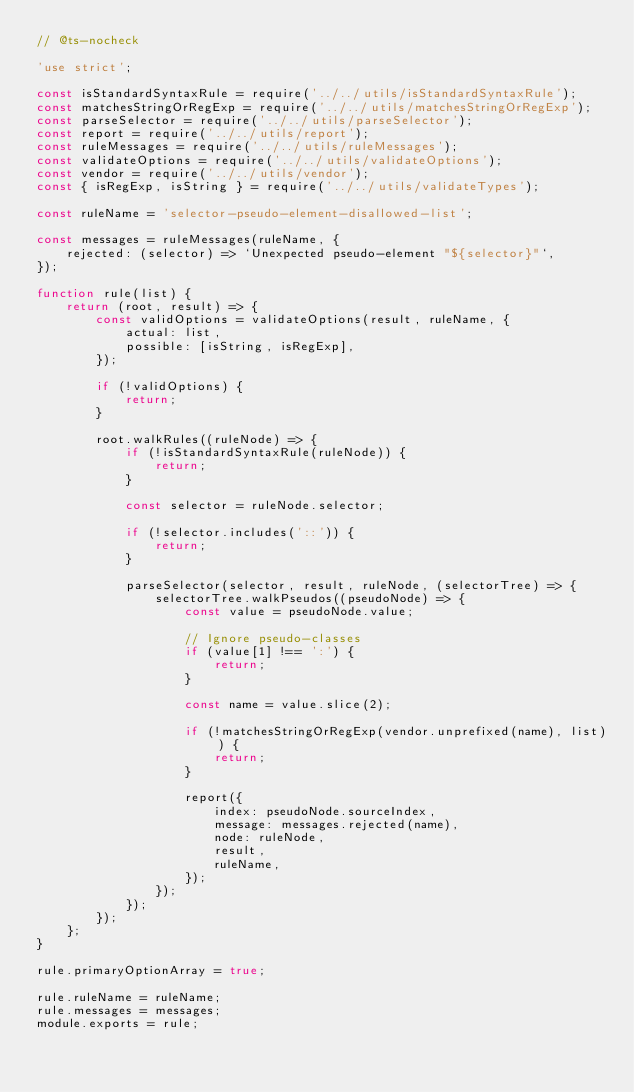<code> <loc_0><loc_0><loc_500><loc_500><_JavaScript_>// @ts-nocheck

'use strict';

const isStandardSyntaxRule = require('../../utils/isStandardSyntaxRule');
const matchesStringOrRegExp = require('../../utils/matchesStringOrRegExp');
const parseSelector = require('../../utils/parseSelector');
const report = require('../../utils/report');
const ruleMessages = require('../../utils/ruleMessages');
const validateOptions = require('../../utils/validateOptions');
const vendor = require('../../utils/vendor');
const { isRegExp, isString } = require('../../utils/validateTypes');

const ruleName = 'selector-pseudo-element-disallowed-list';

const messages = ruleMessages(ruleName, {
	rejected: (selector) => `Unexpected pseudo-element "${selector}"`,
});

function rule(list) {
	return (root, result) => {
		const validOptions = validateOptions(result, ruleName, {
			actual: list,
			possible: [isString, isRegExp],
		});

		if (!validOptions) {
			return;
		}

		root.walkRules((ruleNode) => {
			if (!isStandardSyntaxRule(ruleNode)) {
				return;
			}

			const selector = ruleNode.selector;

			if (!selector.includes('::')) {
				return;
			}

			parseSelector(selector, result, ruleNode, (selectorTree) => {
				selectorTree.walkPseudos((pseudoNode) => {
					const value = pseudoNode.value;

					// Ignore pseudo-classes
					if (value[1] !== ':') {
						return;
					}

					const name = value.slice(2);

					if (!matchesStringOrRegExp(vendor.unprefixed(name), list)) {
						return;
					}

					report({
						index: pseudoNode.sourceIndex,
						message: messages.rejected(name),
						node: ruleNode,
						result,
						ruleName,
					});
				});
			});
		});
	};
}

rule.primaryOptionArray = true;

rule.ruleName = ruleName;
rule.messages = messages;
module.exports = rule;
</code> 